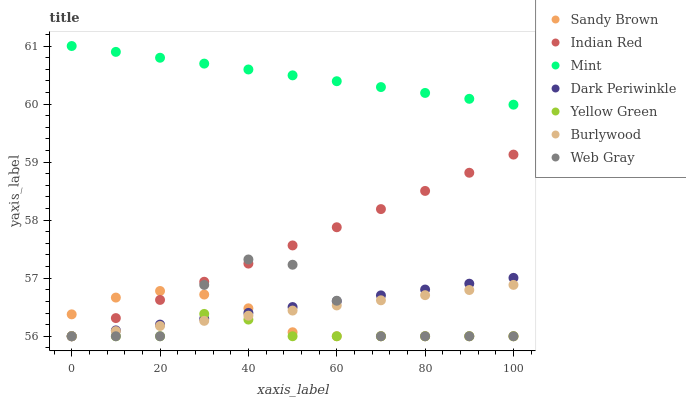Does Yellow Green have the minimum area under the curve?
Answer yes or no. Yes. Does Mint have the maximum area under the curve?
Answer yes or no. Yes. Does Burlywood have the minimum area under the curve?
Answer yes or no. No. Does Burlywood have the maximum area under the curve?
Answer yes or no. No. Is Mint the smoothest?
Answer yes or no. Yes. Is Web Gray the roughest?
Answer yes or no. Yes. Is Yellow Green the smoothest?
Answer yes or no. No. Is Yellow Green the roughest?
Answer yes or no. No. Does Web Gray have the lowest value?
Answer yes or no. Yes. Does Mint have the lowest value?
Answer yes or no. No. Does Mint have the highest value?
Answer yes or no. Yes. Does Burlywood have the highest value?
Answer yes or no. No. Is Sandy Brown less than Mint?
Answer yes or no. Yes. Is Mint greater than Dark Periwinkle?
Answer yes or no. Yes. Does Dark Periwinkle intersect Indian Red?
Answer yes or no. Yes. Is Dark Periwinkle less than Indian Red?
Answer yes or no. No. Is Dark Periwinkle greater than Indian Red?
Answer yes or no. No. Does Sandy Brown intersect Mint?
Answer yes or no. No. 